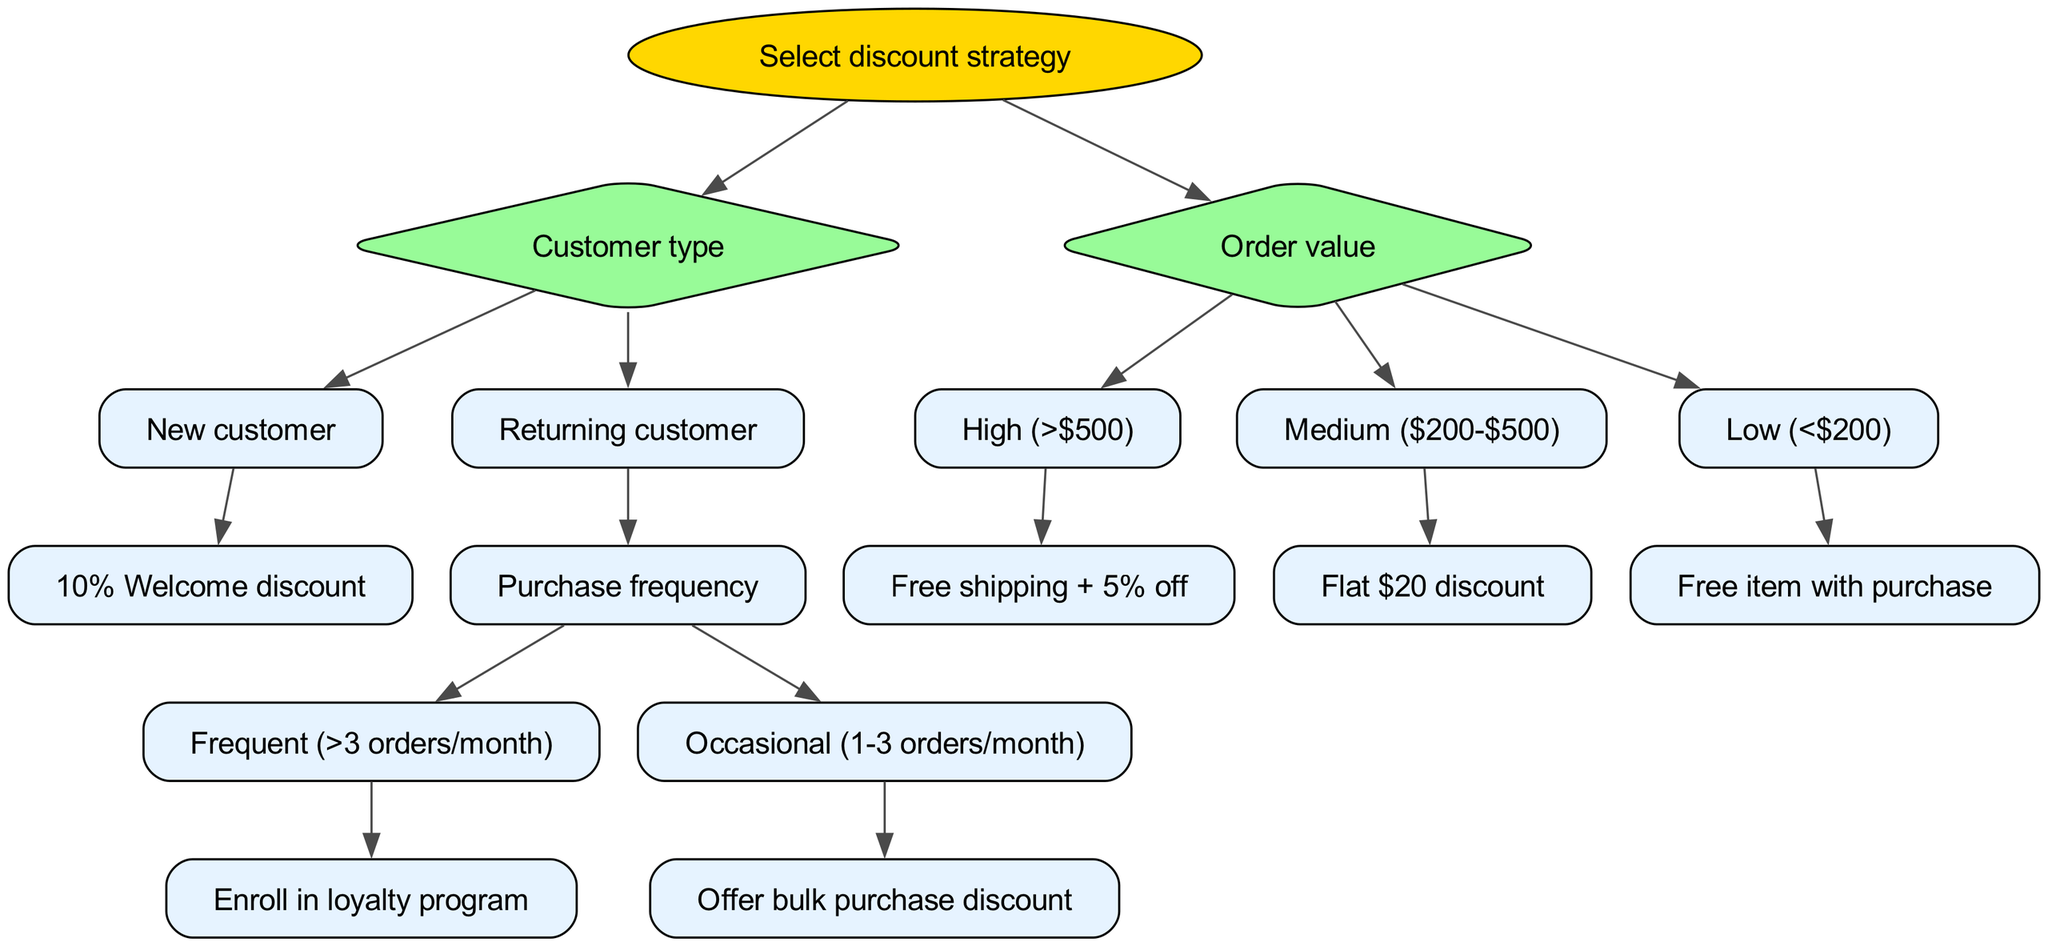What is the root node of the decision tree? The root node is the starting point of the decision tree, which outlines the primary decision to be made. According to the diagram, the root node is "Select discount strategy."
Answer: Select discount strategy How many nodes are there under "Customer type"? The "Customer type" node branches into two nodes: "New customer" and "Returning customer." Therefore, there are two nodes directly under "Customer type."
Answer: 2 What discount is offered to new customers? The discount offered to new customers is clearly indicated as a 10% Welcome discount. It is directly linked to the "New customer" node.
Answer: 10% Welcome discount If a returning customer makes frequent purchases, what discount strategy is applied? The inquiry refers to the "Returning customer" branch that further leads to the "Purchase frequency" node, and identifies "Frequent" as more than three orders per month. The decision made for frequent purchasers is to "Enroll in loyalty program."
Answer: Enroll in loyalty program What is the discount for high order value customers? The high order value is defined as any order exceeding $500, and the corresponding discount strategy is that they receive free shipping plus a 5% discount. This is specified under the "High (>$500)" node.
Answer: Free shipping + 5% off How is the discount determined for customers with low order value? The "Order value" node defines the conditions for low order value customers as anything less than $200. The corresponding strategy offered is a free item with purchase, revealed in the "Low (<$200)" subtree.
Answer: Free item with purchase What are the two classifications for purchase frequency under returning customers? Within the "Returning customer" segment, the purchase frequency is classified into "Frequent (>3 orders/month)" and "Occasional (1-3 orders/month)." This is a direct representation in the decision tree's structure.
Answer: Frequent and Occasional What does a returning customer with occasional purchases receive? The diagram specifies that if a returning customer falls under the occasional category, meaning they make 1-3 orders per month, they would receive a bulk purchase discount, clearly outlined in that branch of the tree.
Answer: Offer bulk purchase discount What additional benefit is provided to customers with medium order value? For medium order value brackets, defined as orders ranging from $200 to $500, the strategy is a flat $20 discount, indicated under the medium value node of the decision tree.
Answer: Flat $20 discount 